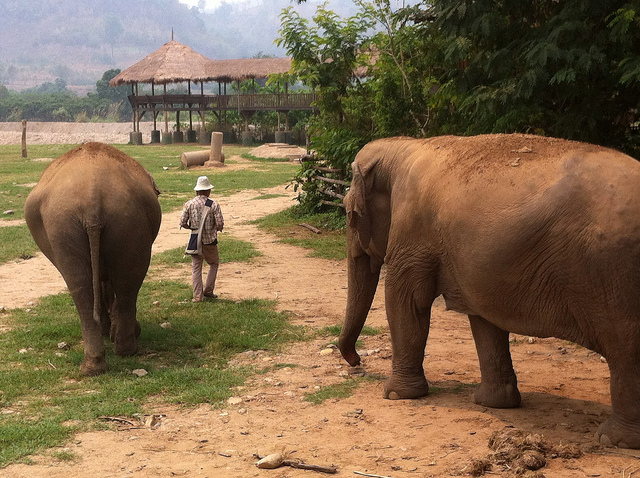Can you describe the attire and equipment of the man in the image, and what does it suggest about his role or activity? The man in the image is dressed in a light-colored shirt, dark pants, and a white hat, which suggests practicality and comfort, critical for spending time outdoors in a warm climate. In his hand, he appears to hold a tool or a walking stick, which could be used for navigating the terrain or for directing the elephants. This ensemble, along with his calm demeanor around the large animals, hints at his role as a caretaker or guide within the sanctuary. 